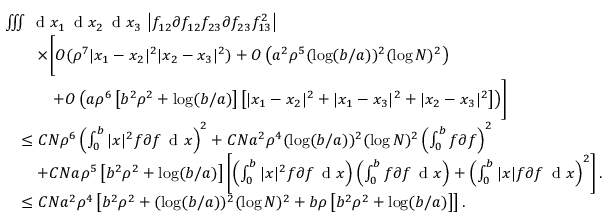Convert formula to latex. <formula><loc_0><loc_0><loc_500><loc_500>\begin{array} { r l } & { \iiint \, d x _ { 1 } \, d x _ { 2 } \, d x _ { 3 } \, \left | f _ { 1 2 } \partial f _ { 1 2 } f _ { 2 3 } \partial f _ { 2 3 } f _ { 1 3 } ^ { 2 } \right | } \\ & { \quad \times \left [ O ( \rho ^ { 7 } | x _ { 1 } - x _ { 2 } | ^ { 2 } | x _ { 2 } - x _ { 3 } | ^ { 2 } ) + O \left ( a ^ { 2 } \rho ^ { 5 } ( \log ( b / a ) ) ^ { 2 } ( \log N ) ^ { 2 } \right ) } \\ & { \quad + O \left ( a \rho ^ { 6 } \left [ b ^ { 2 } \rho ^ { 2 } + \log ( b / a ) \right ] \left [ | x _ { 1 } - x _ { 2 } | ^ { 2 } + | x _ { 1 } - x _ { 3 } | ^ { 2 } + | x _ { 2 } - x _ { 3 } | ^ { 2 } \right ] \right ) \right ] } \\ & { \quad \leq C N \rho ^ { 6 } \left ( \int _ { 0 } ^ { b } | x | ^ { 2 } f \partial f \, d x \right ) ^ { 2 } + C N a ^ { 2 } \rho ^ { 4 } ( \log ( b / a ) ) ^ { 2 } ( \log N ) ^ { 2 } \left ( \int _ { 0 } ^ { b } f \partial f \right ) ^ { 2 } } \\ & { \quad + C N a \rho ^ { 5 } \left [ b ^ { 2 } \rho ^ { 2 } + \log ( b / a ) \right ] \left [ \left ( \int _ { 0 } ^ { b } | x | ^ { 2 } f \partial f \, d x \right ) \left ( \int _ { 0 } ^ { b } f \partial f \, d x \right ) + \left ( \int _ { 0 } ^ { b } | x | f \partial f \, d x \right ) ^ { 2 } \right ] . } \\ & { \quad \leq C N a ^ { 2 } \rho ^ { 4 } \left [ b ^ { 2 } \rho ^ { 2 } + ( \log ( b / a ) ) ^ { 2 } ( \log N ) ^ { 2 } + b \rho \left [ b ^ { 2 } \rho ^ { 2 } + \log ( b / a ) \right ] \right ] . } \end{array}</formula> 